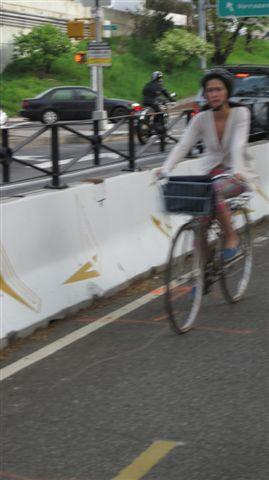How is the women moving?

Choices:
A) bicycling
B) dancing
C) running
D) walking bicycling 